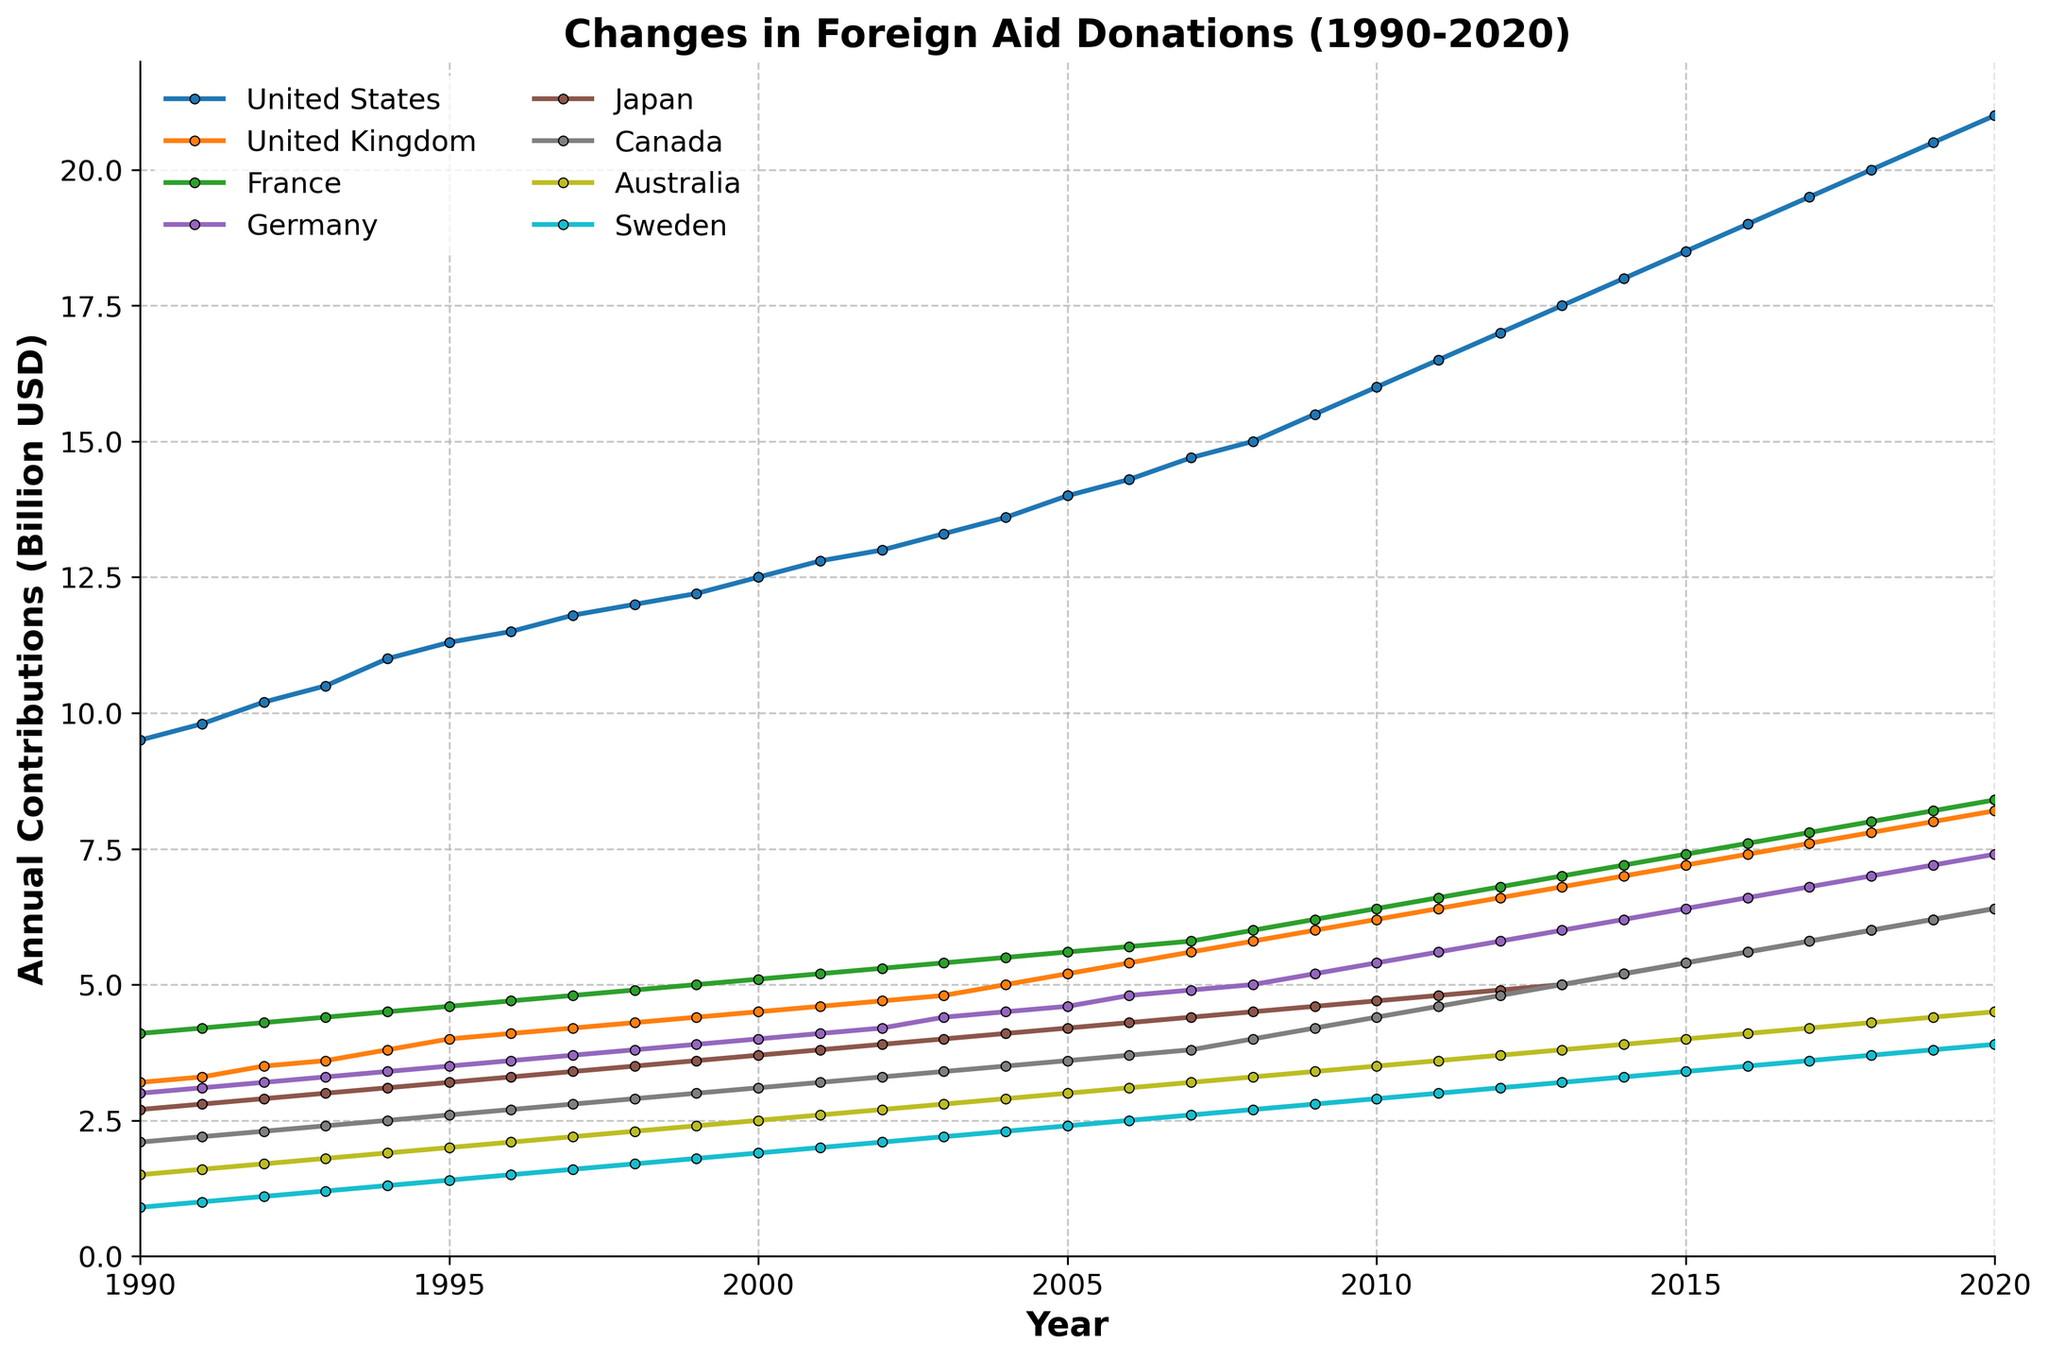What is the title of the figure? The title of the figure is typically displayed at the top of the chart. By looking at the top of this figure, you can see it is labeled.
Answer: Changes in Foreign Aid Donations (1990-2020) What are the units used on the Y-axis? The label on the Y-axis should indicate the units of measurement. The Y-axis label reads "Annual Contributions (Billion USD)".
Answer: Billion USD How many countries are represented in the plot? To find the number of countries, count the number of unique data series or lines in the plot. Each line represents a different country.
Answer: 8 Which country had the highest contribution in 2020? Look at the values in 2020 for all the countries and identify which one has the highest value. In the plot, the United States has the highest value at around 21 billion USD.
Answer: United States What is the trend of foreign aid contributions from the United Kingdom between 1990 and 2020? Observing the line corresponding to the United Kingdom from 1990 to 2020, you can see it generally moves upwards, indicating an increasing trend in contributions.
Answer: Increasing Which country had the lowest contribution in 1990 and how much was it? Evaluate the values for all countries in 1990 and identify the lowest one. According to the plot, Sweden had the lowest contribution at about 0.9 billion USD.
Answer: Sweden, 0.9 billion USD How did the contribution of Japan change from 2000 to 2010? Examine the line for Japan from the year 2000 to 2010. You will notice that the line trends upwards from approximately 3.7 to approximately 4.7 billion USD, indicating an increase.
Answer: Increased by 1 billion USD What is the difference between the 2020 contributions of Canada and Australia? Check the values for Canada and Australia in 2020 and calculate the difference. Canada's contribution is about 6.4 billion USD and Australia's is about 4.5 billion USD, so the difference is 6.4 - 4.5 = 1.9 billion USD.
Answer: 1.9 billion USD Which country showed the most consistent growth in contributions across the time period? To determine consistency in growth, look for a line that steadily increases without significant fluctuations. The United States exhibits a consistent growth pattern from 1990 to 2020.
Answer: United States On average, how much did France contribute annually over the given period? Sum the contributions of France from 1990 to 2020 and then divide by the number of years (31). The sum can be found as follows: (4.1+4.2+4.3+4.4+4.5+4.6+4.7+4.8+4.9+5.0+5.1+5.2+5.3+5.4+5.5+5.6+5.7+5.8+6.0+6.2+6.4+6.6+6.8+7.0+7.2+7.4+7.6+7.8+8.0+8.2+8.4) = 199.1. The average is then 199.1/31 ≈ 6.42 billion USD.
Answer: Approximately 6.42 billion USD 